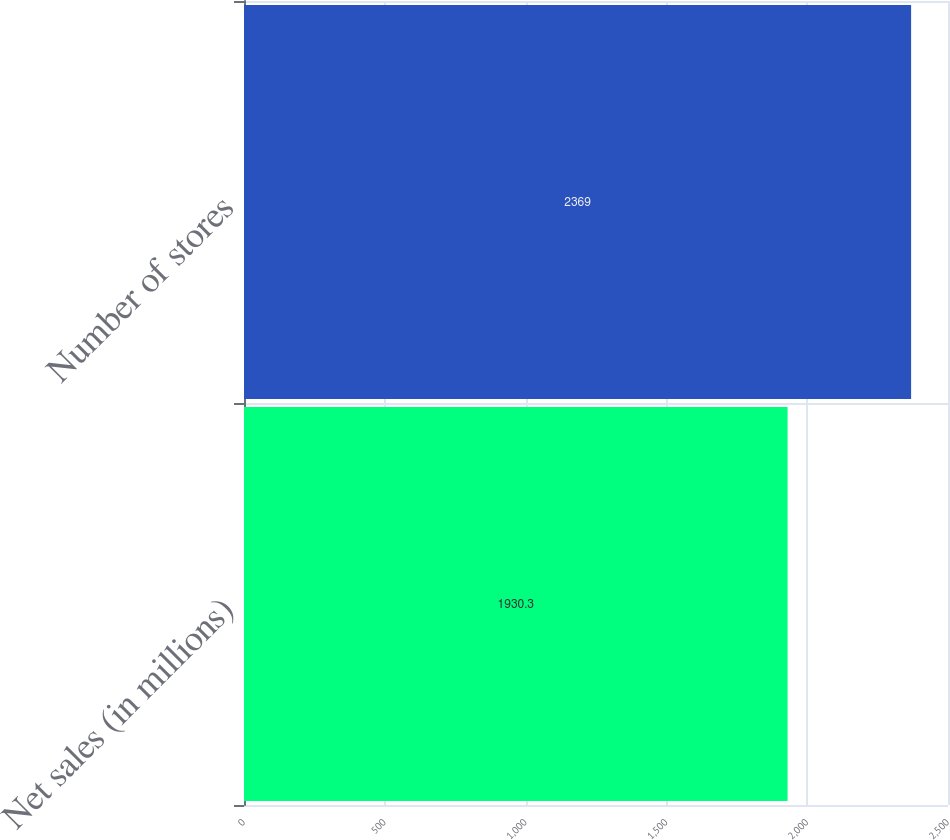<chart> <loc_0><loc_0><loc_500><loc_500><bar_chart><fcel>Net sales (in millions)<fcel>Number of stores<nl><fcel>1930.3<fcel>2369<nl></chart> 